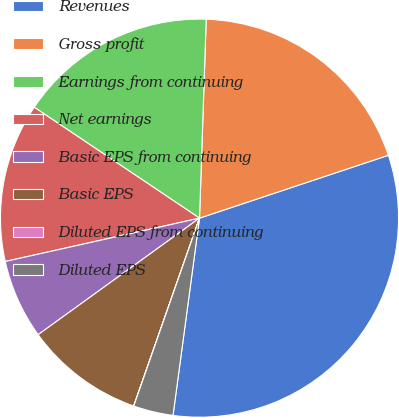<chart> <loc_0><loc_0><loc_500><loc_500><pie_chart><fcel>Revenues<fcel>Gross profit<fcel>Earnings from continuing<fcel>Net earnings<fcel>Basic EPS from continuing<fcel>Basic EPS<fcel>Diluted EPS from continuing<fcel>Diluted EPS<nl><fcel>32.24%<fcel>19.35%<fcel>16.13%<fcel>12.9%<fcel>6.46%<fcel>9.68%<fcel>0.01%<fcel>3.23%<nl></chart> 